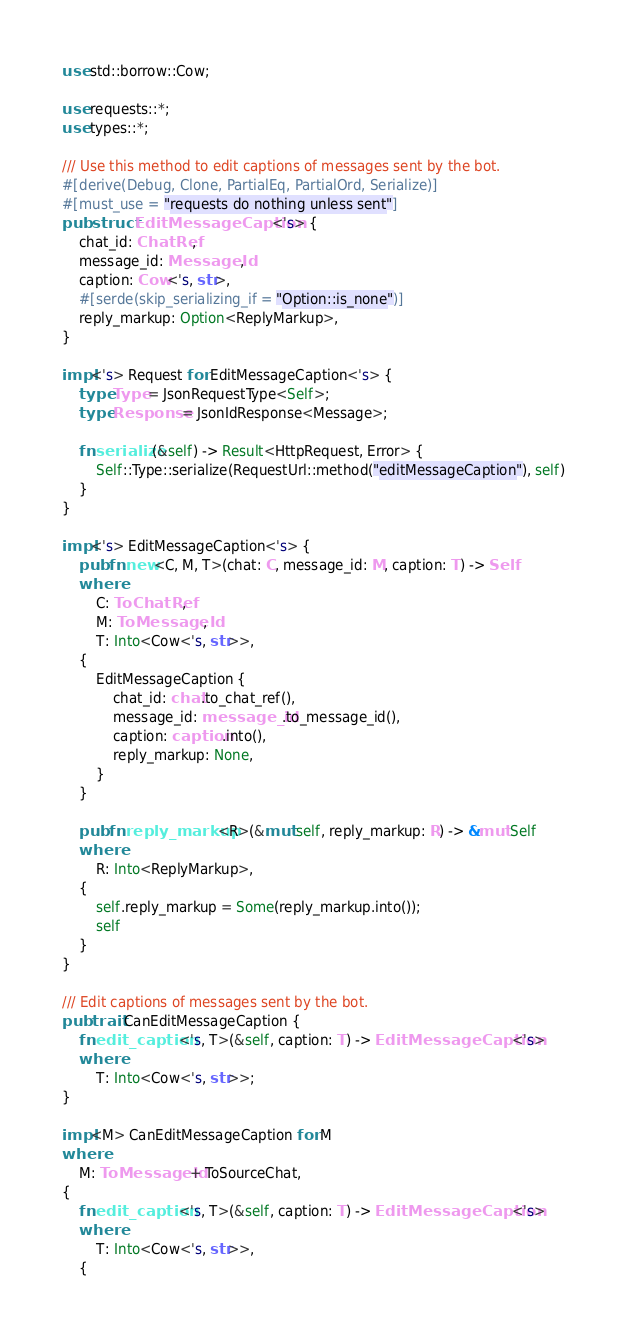Convert code to text. <code><loc_0><loc_0><loc_500><loc_500><_Rust_>use std::borrow::Cow;

use requests::*;
use types::*;

/// Use this method to edit captions of messages sent by the bot.
#[derive(Debug, Clone, PartialEq, PartialOrd, Serialize)]
#[must_use = "requests do nothing unless sent"]
pub struct EditMessageCaption<'s> {
    chat_id: ChatRef,
    message_id: MessageId,
    caption: Cow<'s, str>,
    #[serde(skip_serializing_if = "Option::is_none")]
    reply_markup: Option<ReplyMarkup>,
}

impl<'s> Request for EditMessageCaption<'s> {
    type Type = JsonRequestType<Self>;
    type Response = JsonIdResponse<Message>;

    fn serialize(&self) -> Result<HttpRequest, Error> {
        Self::Type::serialize(RequestUrl::method("editMessageCaption"), self)
    }
}

impl<'s> EditMessageCaption<'s> {
    pub fn new<C, M, T>(chat: C, message_id: M, caption: T) -> Self
    where
        C: ToChatRef,
        M: ToMessageId,
        T: Into<Cow<'s, str>>,
    {
        EditMessageCaption {
            chat_id: chat.to_chat_ref(),
            message_id: message_id.to_message_id(),
            caption: caption.into(),
            reply_markup: None,
        }
    }

    pub fn reply_markup<R>(&mut self, reply_markup: R) -> &mut Self
    where
        R: Into<ReplyMarkup>,
    {
        self.reply_markup = Some(reply_markup.into());
        self
    }
}

/// Edit captions of messages sent by the bot.
pub trait CanEditMessageCaption {
    fn edit_caption<'s, T>(&self, caption: T) -> EditMessageCaption<'s>
    where
        T: Into<Cow<'s, str>>;
}

impl<M> CanEditMessageCaption for M
where
    M: ToMessageId + ToSourceChat,
{
    fn edit_caption<'s, T>(&self, caption: T) -> EditMessageCaption<'s>
    where
        T: Into<Cow<'s, str>>,
    {</code> 